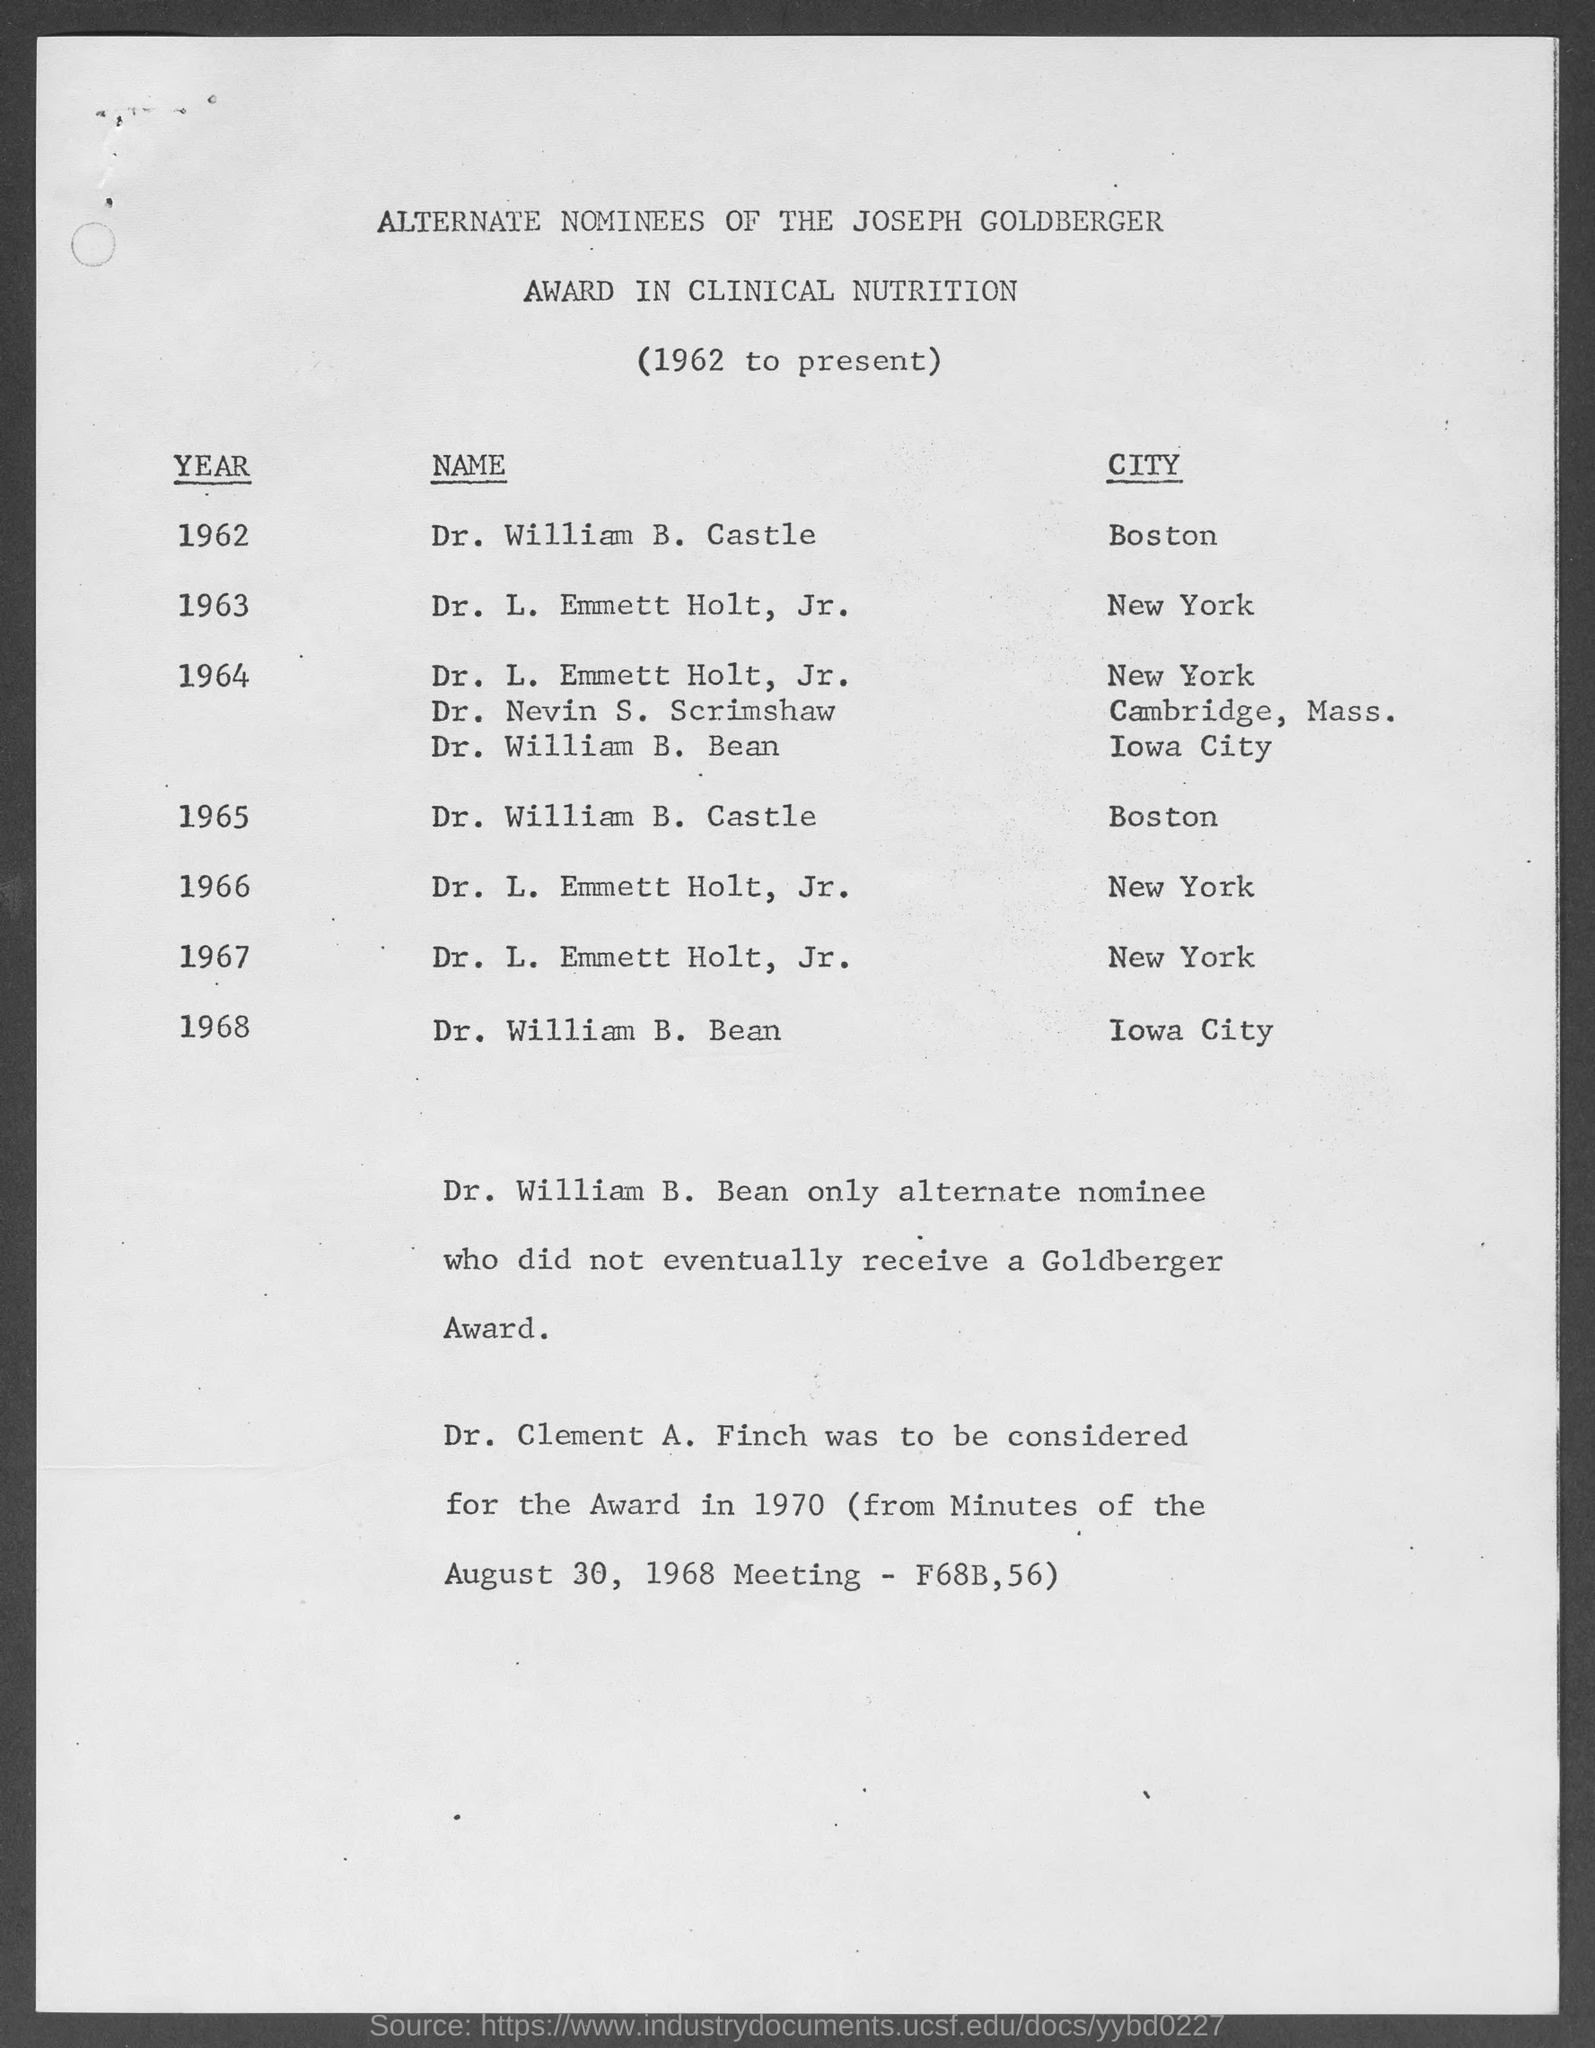Who was to be considered  for the award in 1970 (from Minutes of the August 30, 1968 Meeting - F68B,56)?
Your answer should be compact. Dr. Clement A. Finch. Who was the only alternative who did not eventually receive a Goldberger Award?
Give a very brief answer. Dr. William B. Bean. Who was the alternate nominee of the Joseph Goldberger Award in Clinical Nutrition for the year 1963 in New York?
Provide a succinct answer. Dr. L. Emmett Holt, Jr. Who was the alternate nominee of the Joseph Goldberger Award in Clinical Nutrition for the year 1962 in Boston?
Make the answer very short. Dr. William B. Castle. Who was the alternate nominee of the Joseph Goldberger Award in Clinical Nutrition for the year 1968 in Iowa City?
Your answer should be very brief. Dr. William B. Bean. 